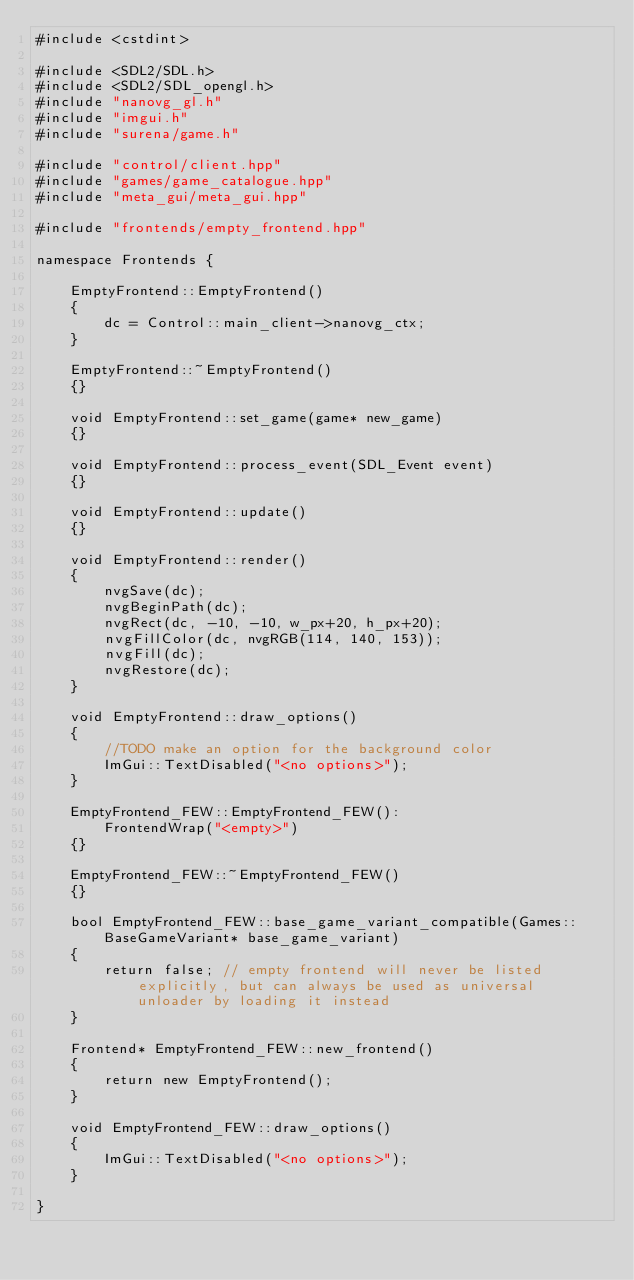<code> <loc_0><loc_0><loc_500><loc_500><_C++_>#include <cstdint>

#include <SDL2/SDL.h>
#include <SDL2/SDL_opengl.h>
#include "nanovg_gl.h"
#include "imgui.h"
#include "surena/game.h"

#include "control/client.hpp"
#include "games/game_catalogue.hpp"
#include "meta_gui/meta_gui.hpp"

#include "frontends/empty_frontend.hpp"

namespace Frontends {

    EmptyFrontend::EmptyFrontend()
    {
        dc = Control::main_client->nanovg_ctx;
    }

    EmptyFrontend::~EmptyFrontend()
    {}

    void EmptyFrontend::set_game(game* new_game)
    {}

    void EmptyFrontend::process_event(SDL_Event event)
    {}

    void EmptyFrontend::update()
    {}

    void EmptyFrontend::render()
    {
        nvgSave(dc);
        nvgBeginPath(dc);
        nvgRect(dc, -10, -10, w_px+20, h_px+20);
        nvgFillColor(dc, nvgRGB(114, 140, 153));
        nvgFill(dc);
        nvgRestore(dc);
    }

    void EmptyFrontend::draw_options()
    {
        //TODO make an option for the background color
        ImGui::TextDisabled("<no options>");
    }

    EmptyFrontend_FEW::EmptyFrontend_FEW():
        FrontendWrap("<empty>")
    {}

    EmptyFrontend_FEW::~EmptyFrontend_FEW()
    {}
    
    bool EmptyFrontend_FEW::base_game_variant_compatible(Games::BaseGameVariant* base_game_variant)
    {
        return false; // empty frontend will never be listed explicitly, but can always be used as universal unloader by loading it instead
    }
    
    Frontend* EmptyFrontend_FEW::new_frontend()
    {
        return new EmptyFrontend();
    }

    void EmptyFrontend_FEW::draw_options()
    {
        ImGui::TextDisabled("<no options>");
    }

}
</code> 